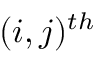Convert formula to latex. <formula><loc_0><loc_0><loc_500><loc_500>( i , j ) ^ { t h }</formula> 